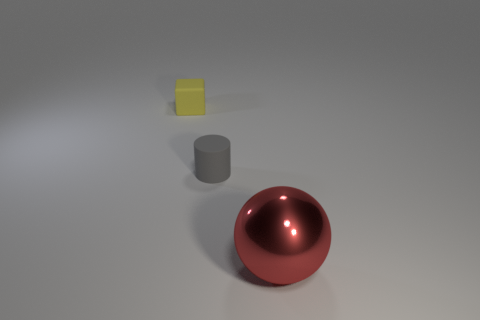What is the shape of the gray thing that is the same size as the cube?
Offer a terse response. Cylinder. What number of objects are either things that are behind the big thing or blue cylinders?
Ensure brevity in your answer.  2. Is the large metal object the same color as the tiny matte block?
Provide a short and direct response. No. What is the size of the object that is in front of the gray thing?
Your answer should be very brief. Large. Are there any yellow rubber things that have the same size as the cube?
Provide a succinct answer. No. Do the matte thing to the left of the gray matte cylinder and the big red metallic object have the same size?
Make the answer very short. No. How big is the red thing?
Make the answer very short. Large. What color is the small thing left of the matte object that is right of the tiny thing left of the cylinder?
Your answer should be very brief. Yellow. There is a small rubber thing that is to the right of the tiny block; does it have the same color as the big shiny sphere?
Keep it short and to the point. No. How many objects are to the left of the ball and in front of the matte cube?
Offer a very short reply. 1. 